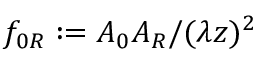Convert formula to latex. <formula><loc_0><loc_0><loc_500><loc_500>f _ { 0 R } \colon = A _ { 0 } A _ { R } / ( \lambda z ) ^ { 2 }</formula> 